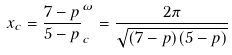<formula> <loc_0><loc_0><loc_500><loc_500>x _ { c } = \frac { 7 - p } { 5 - p } ^ { \omega } _ { c } = \frac { 2 \pi } { \sqrt { ( 7 - p ) ( 5 - p ) } }</formula> 